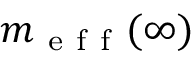<formula> <loc_0><loc_0><loc_500><loc_500>m _ { e f f } ( \infty )</formula> 